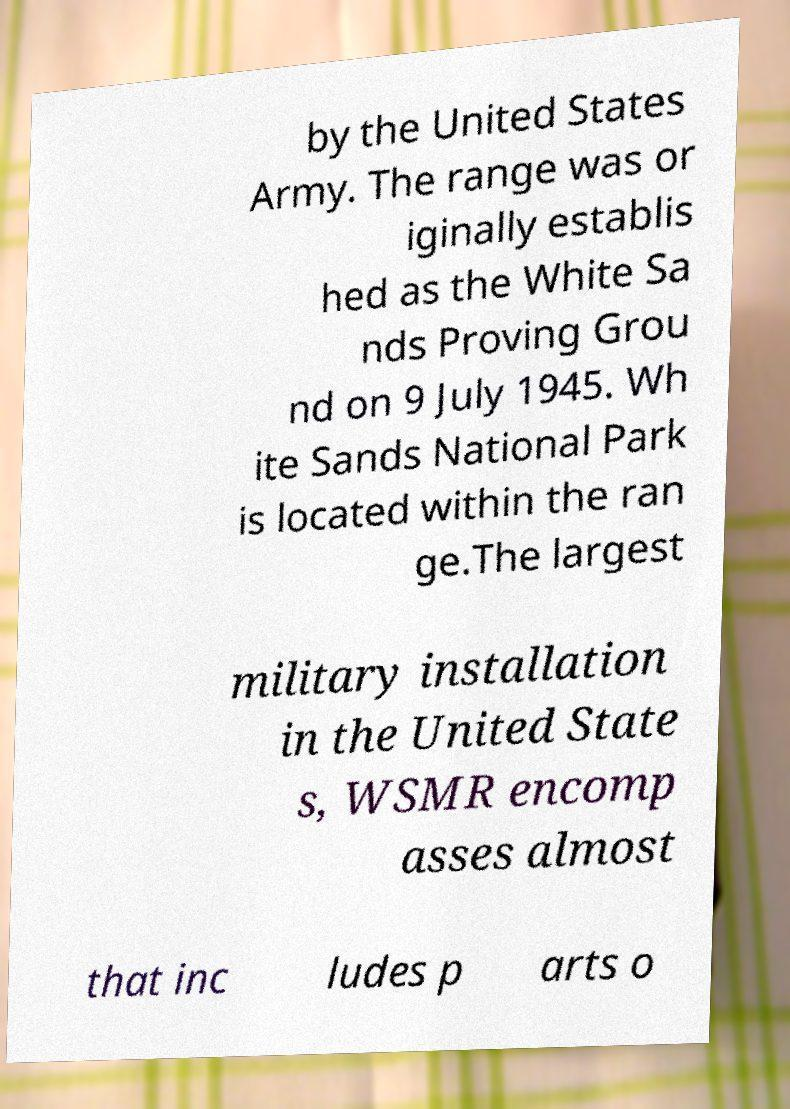Could you extract and type out the text from this image? by the United States Army. The range was or iginally establis hed as the White Sa nds Proving Grou nd on 9 July 1945. Wh ite Sands National Park is located within the ran ge.The largest military installation in the United State s, WSMR encomp asses almost that inc ludes p arts o 